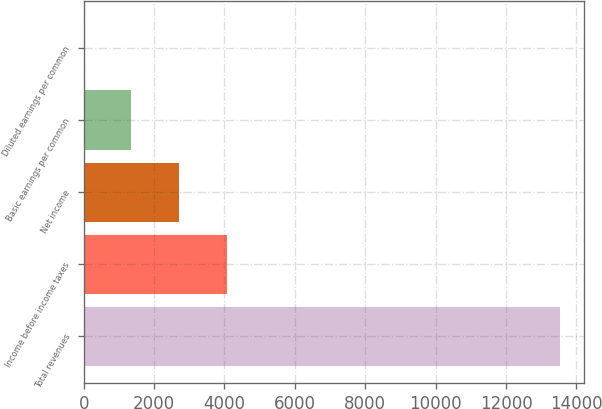Convert chart. <chart><loc_0><loc_0><loc_500><loc_500><bar_chart><fcel>Total revenues<fcel>Income before income taxes<fcel>Net income<fcel>Basic earnings per common<fcel>Diluted earnings per common<nl><fcel>13534<fcel>4063.31<fcel>2710.36<fcel>1357.41<fcel>4.46<nl></chart> 